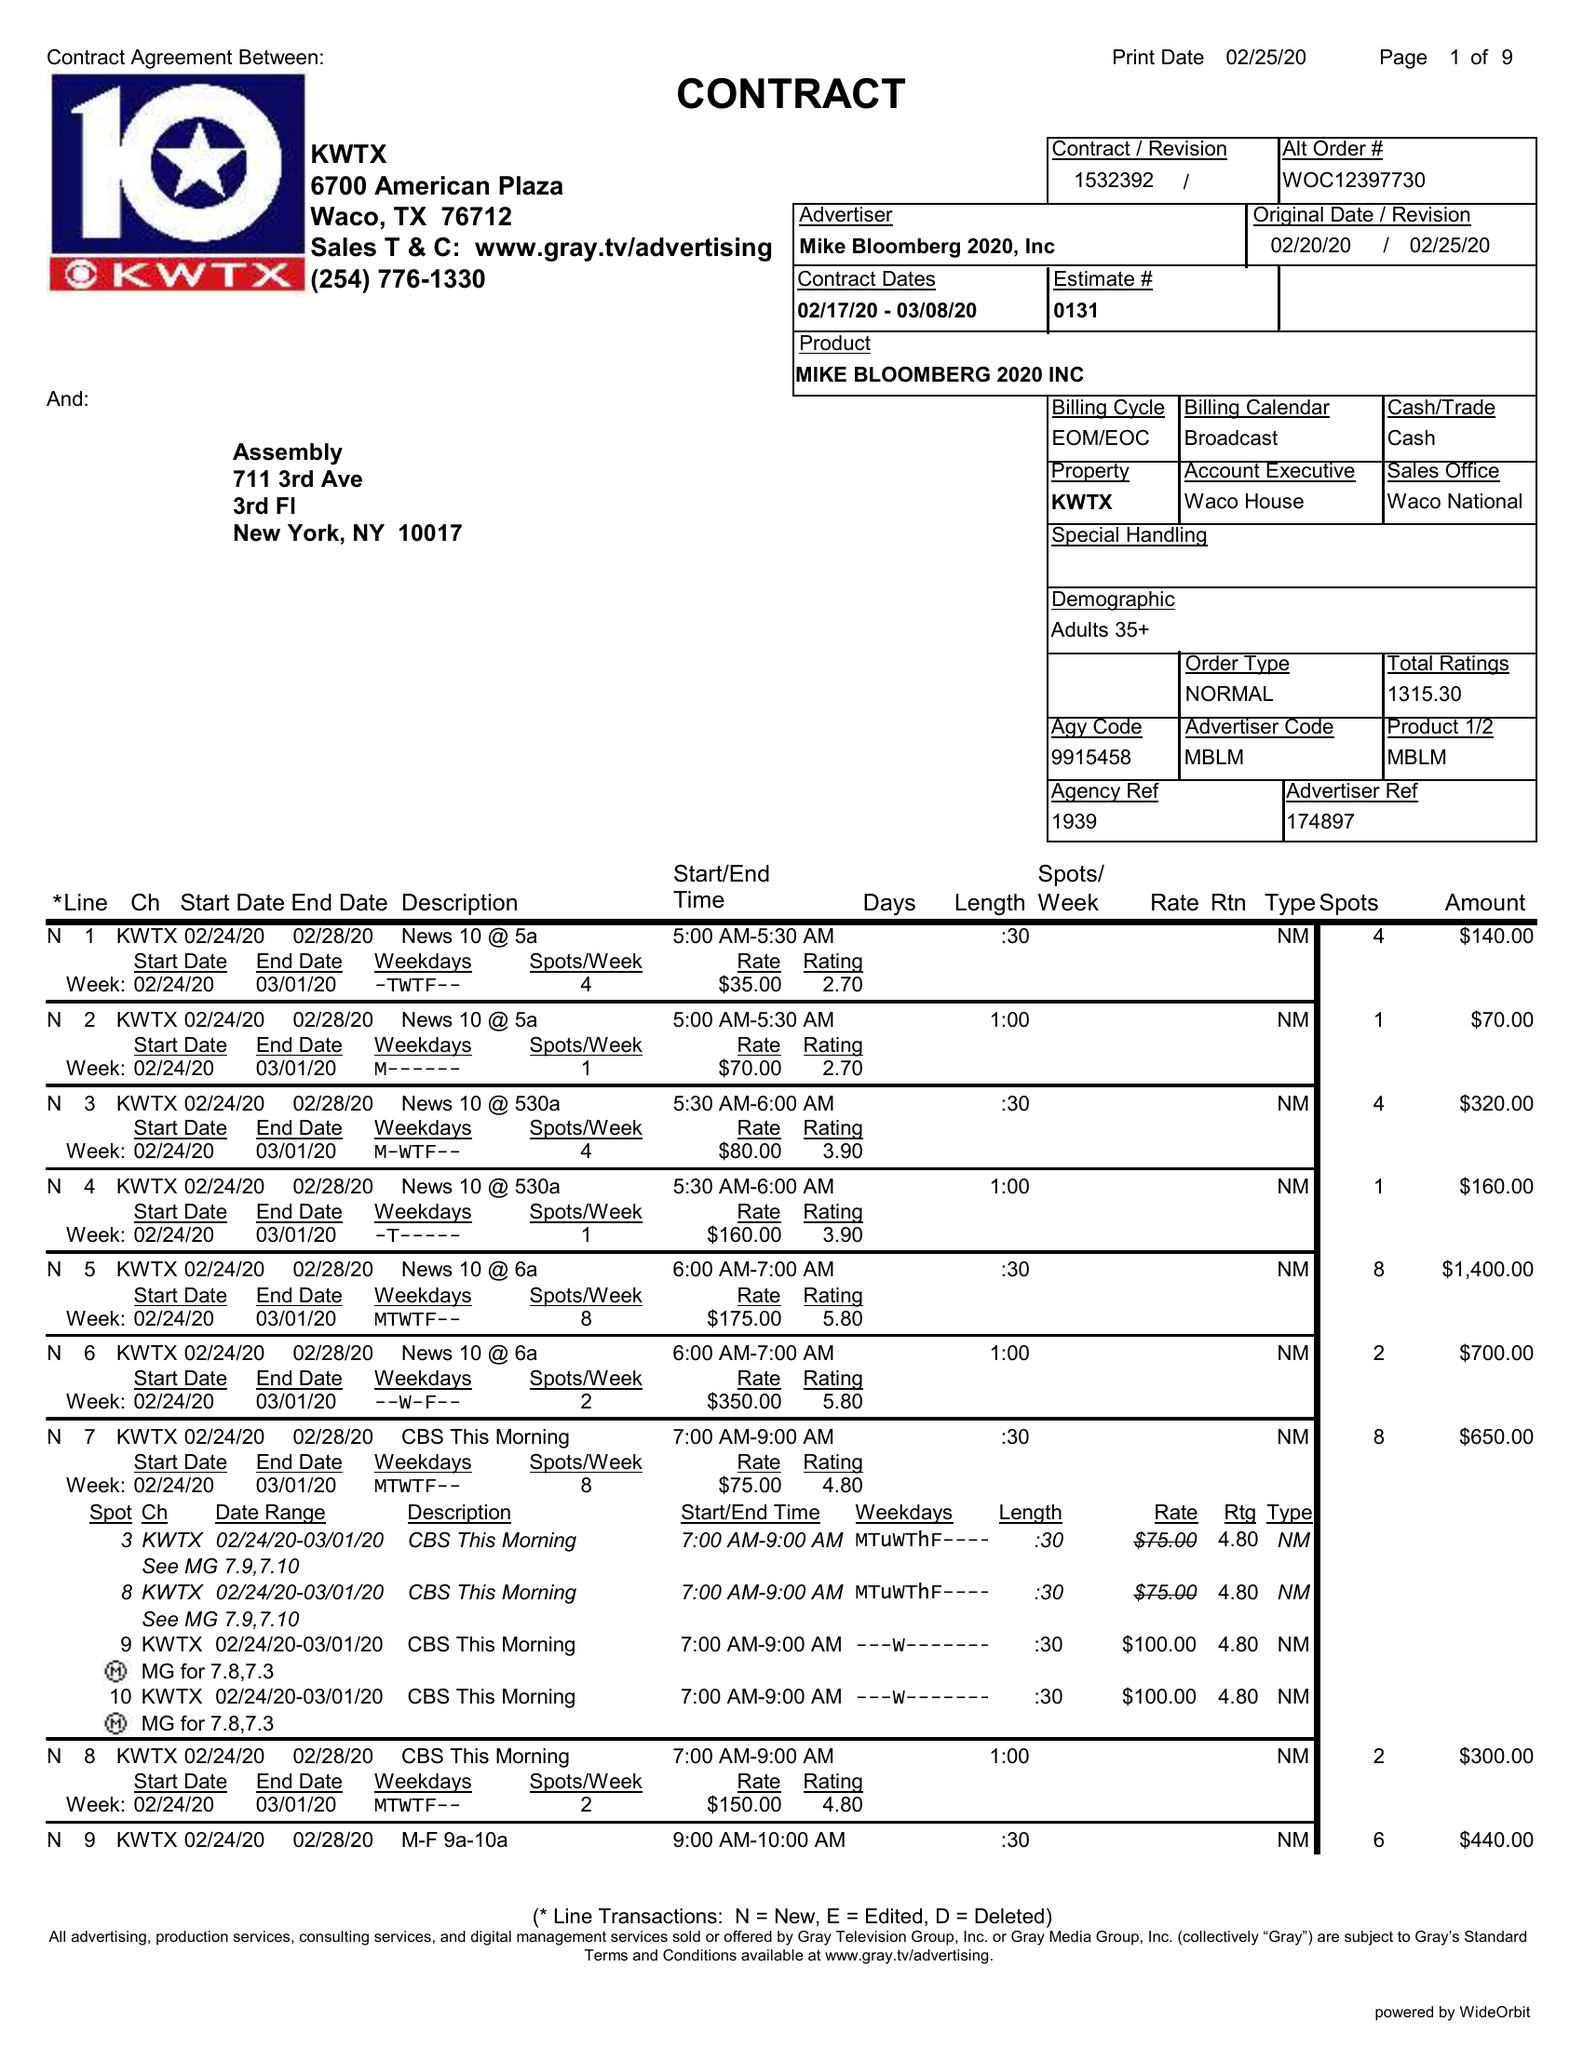What is the value for the advertiser?
Answer the question using a single word or phrase. MIKE BLOOMBERG 2020, INC 